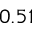<formula> <loc_0><loc_0><loc_500><loc_500>0 . 5 1</formula> 